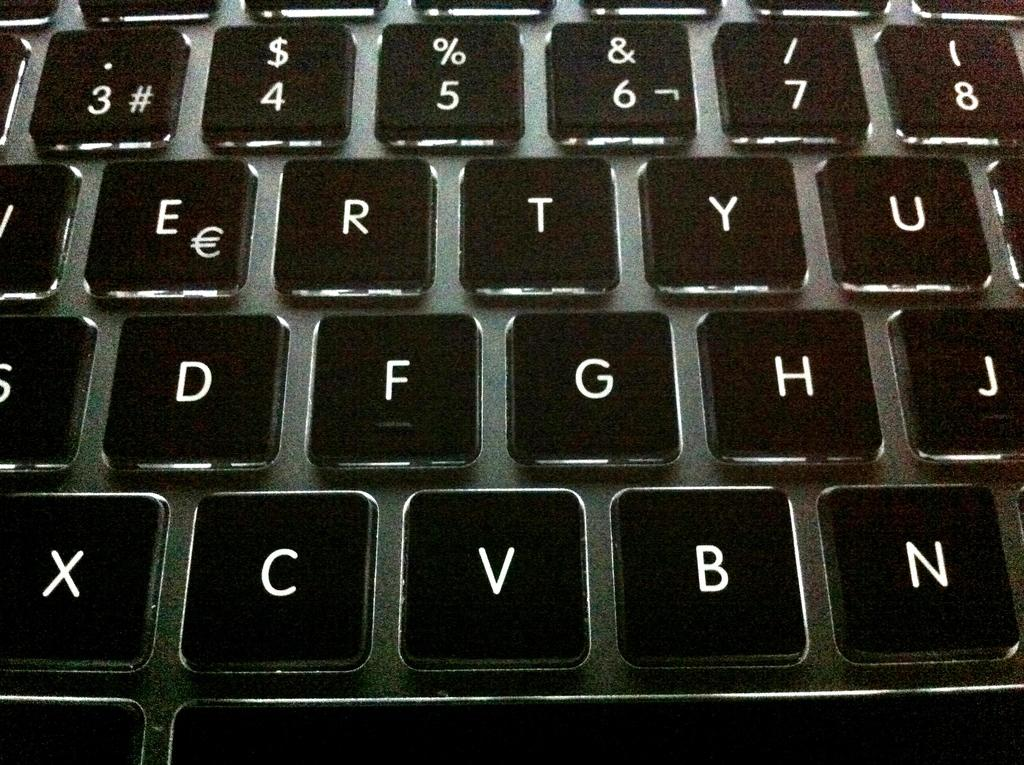What is the main object in the image? There is a keyboard in the image. What type of soup is being served on the plate next to the keyboard in the image? There is no soup or plate present in the image; it only features a keyboard. 